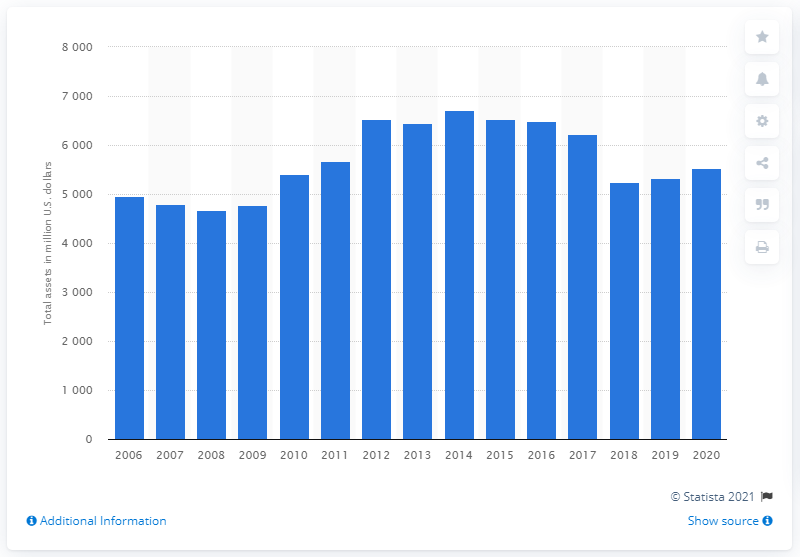Identify some key points in this picture. Mattel's assets in dollars in 2020 were valued at 55,210.90. 